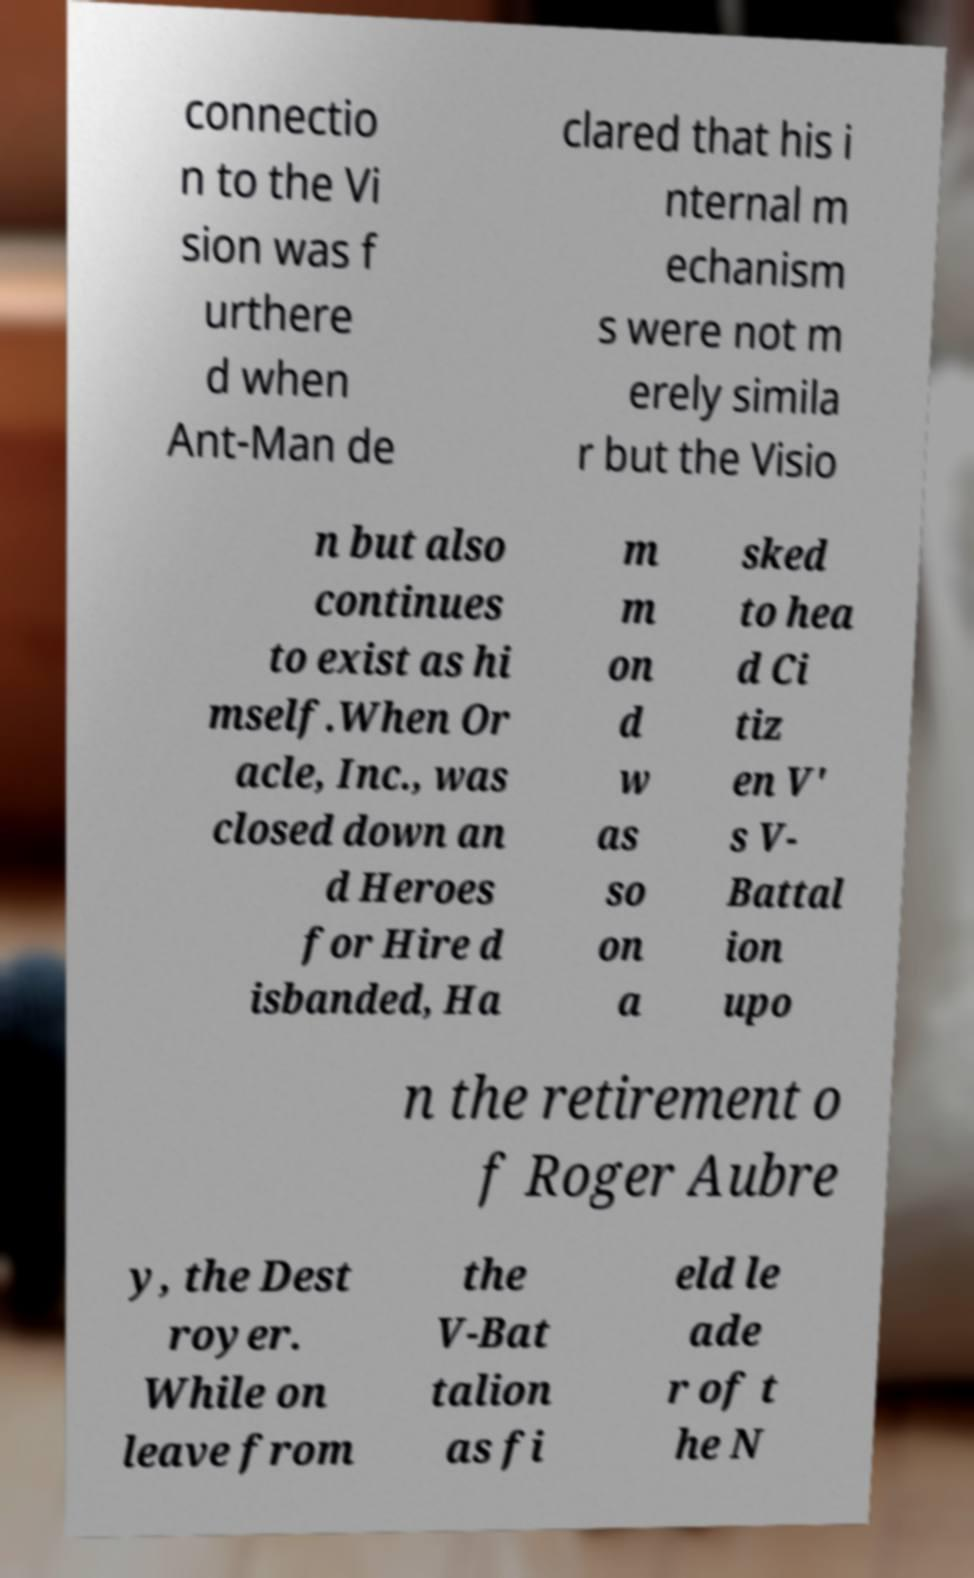I need the written content from this picture converted into text. Can you do that? connectio n to the Vi sion was f urthere d when Ant-Man de clared that his i nternal m echanism s were not m erely simila r but the Visio n but also continues to exist as hi mself.When Or acle, Inc., was closed down an d Heroes for Hire d isbanded, Ha m m on d w as so on a sked to hea d Ci tiz en V' s V- Battal ion upo n the retirement o f Roger Aubre y, the Dest royer. While on leave from the V-Bat talion as fi eld le ade r of t he N 